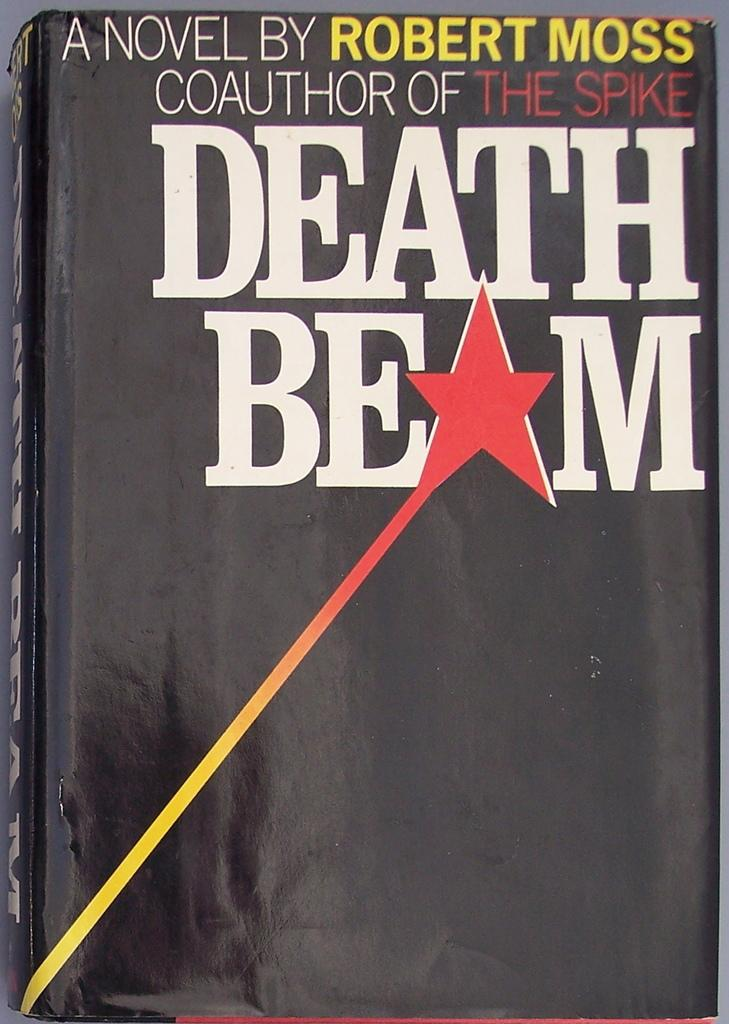<image>
Create a compact narrative representing the image presented. A book called Death Beam by Robert Moss. 